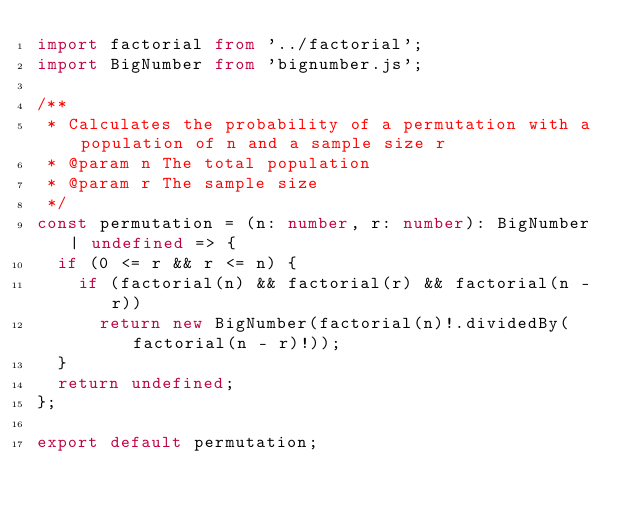<code> <loc_0><loc_0><loc_500><loc_500><_TypeScript_>import factorial from '../factorial';
import BigNumber from 'bignumber.js';

/**
 * Calculates the probability of a permutation with a population of n and a sample size r
 * @param n The total population
 * @param r The sample size
 */
const permutation = (n: number, r: number): BigNumber | undefined => {
  if (0 <= r && r <= n) {
    if (factorial(n) && factorial(r) && factorial(n - r))
      return new BigNumber(factorial(n)!.dividedBy(factorial(n - r)!));
  }
  return undefined;
};

export default permutation;
</code> 